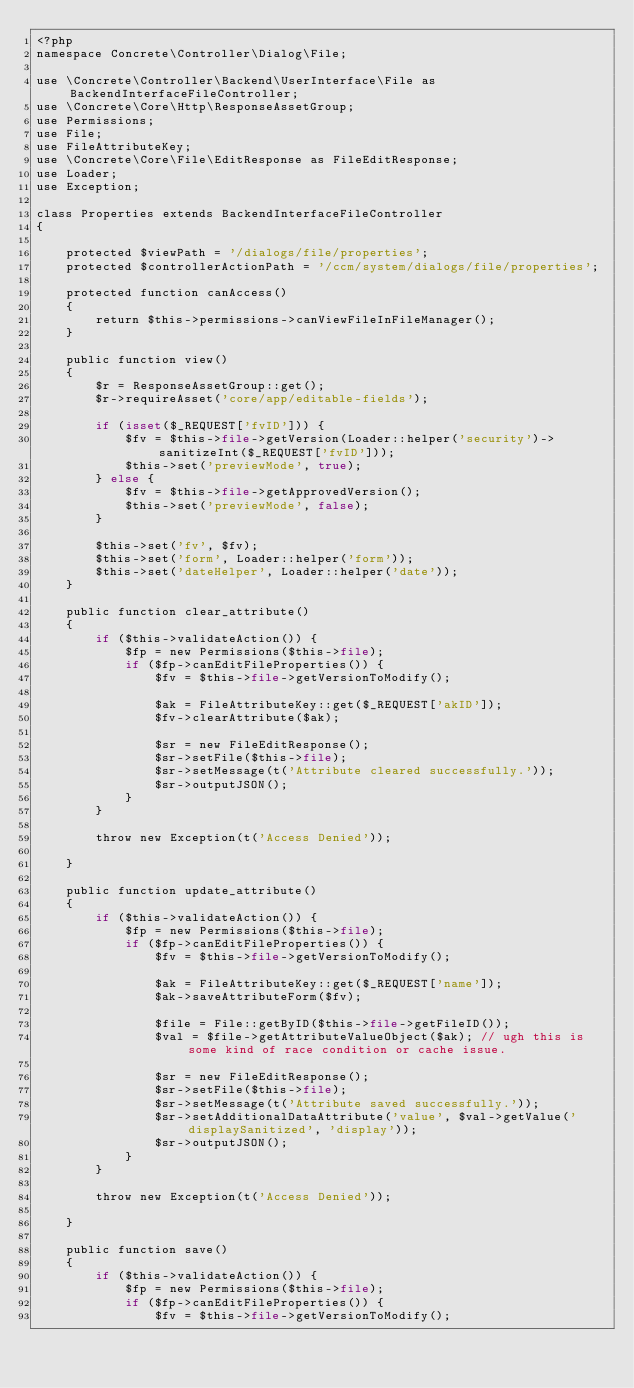Convert code to text. <code><loc_0><loc_0><loc_500><loc_500><_PHP_><?php
namespace Concrete\Controller\Dialog\File;

use \Concrete\Controller\Backend\UserInterface\File as BackendInterfaceFileController;
use \Concrete\Core\Http\ResponseAssetGroup;
use Permissions;
use File;
use FileAttributeKey;
use \Concrete\Core\File\EditResponse as FileEditResponse;
use Loader;
use Exception;

class Properties extends BackendInterfaceFileController
{

    protected $viewPath = '/dialogs/file/properties';
    protected $controllerActionPath = '/ccm/system/dialogs/file/properties';

    protected function canAccess()
    {
        return $this->permissions->canViewFileInFileManager();
    }

    public function view()
    {
        $r = ResponseAssetGroup::get();
        $r->requireAsset('core/app/editable-fields');

        if (isset($_REQUEST['fvID'])) {
            $fv = $this->file->getVersion(Loader::helper('security')->sanitizeInt($_REQUEST['fvID']));
            $this->set('previewMode', true);
        } else {
            $fv = $this->file->getApprovedVersion();
            $this->set('previewMode', false);
        }

        $this->set('fv', $fv);
        $this->set('form', Loader::helper('form'));
        $this->set('dateHelper', Loader::helper('date'));
    }

    public function clear_attribute()
    {
        if ($this->validateAction()) {
            $fp = new Permissions($this->file);
            if ($fp->canEditFileProperties()) {
                $fv = $this->file->getVersionToModify();

                $ak = FileAttributeKey::get($_REQUEST['akID']);
                $fv->clearAttribute($ak);

                $sr = new FileEditResponse();
                $sr->setFile($this->file);
                $sr->setMessage(t('Attribute cleared successfully.'));
                $sr->outputJSON();
            }
        }

        throw new Exception(t('Access Denied'));

    }

    public function update_attribute()
    {
        if ($this->validateAction()) {
            $fp = new Permissions($this->file);
            if ($fp->canEditFileProperties()) {
                $fv = $this->file->getVersionToModify();

                $ak = FileAttributeKey::get($_REQUEST['name']);
                $ak->saveAttributeForm($fv);

                $file = File::getByID($this->file->getFileID());
                $val = $file->getAttributeValueObject($ak); // ugh this is some kind of race condition or cache issue.

                $sr = new FileEditResponse();
                $sr->setFile($this->file);
                $sr->setMessage(t('Attribute saved successfully.'));
                $sr->setAdditionalDataAttribute('value', $val->getValue('displaySanitized', 'display'));
                $sr->outputJSON();
            }
        }

        throw new Exception(t('Access Denied'));

    }

    public function save()
    {
        if ($this->validateAction()) {
            $fp = new Permissions($this->file);
            if ($fp->canEditFileProperties()) {
                $fv = $this->file->getVersionToModify();</code> 